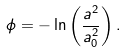<formula> <loc_0><loc_0><loc_500><loc_500>\phi = - \ln \left ( \frac { a ^ { 2 } } { a _ { 0 } ^ { 2 } } \right ) .</formula> 